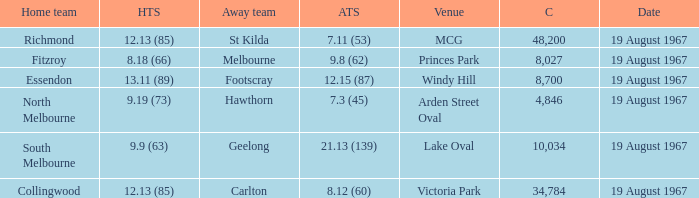What did the away team score when they were playing collingwood? 8.12 (60). 